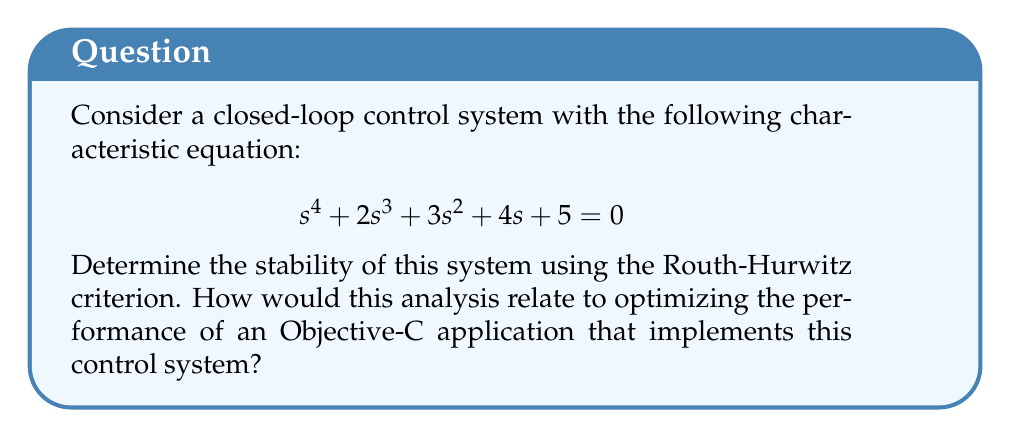Teach me how to tackle this problem. To determine the stability of the system using the Routh-Hurwitz criterion, we'll follow these steps:

1. Construct the Routh array:

   $$\begin{array}{c|cccc}
   s^4 & 1 & 3 & 5 \\
   s^3 & 2 & 4 & 0 \\
   s^2 & b_1 & b_2 & \\
   s^1 & c_1 & & \\
   s^0 & d_1 & & 
   \end{array}$$

2. Calculate the elements of the array:

   $b_1 = \frac{(2)(3) - (1)(4)}{2} = 1$
   
   $b_2 = \frac{(2)(5) - (1)(0)}{2} = 5$
   
   $c_1 = \frac{(1)(4) - (2)(5)}{1} = -6$
   
   $d_1 = 5$ (last element of the first column)

3. The complete Routh array:

   $$\begin{array}{c|cccc}
   s^4 & 1 & 3 & 5 \\
   s^3 & 2 & 4 & 0 \\
   s^2 & 1 & 5 & \\
   s^1 & -6 & & \\
   s^0 & 5 & & 
   \end{array}$$

4. Analyze the first column of the Routh array:
   - There is a sign change between -6 and 5 in the first column.
   - According to the Routh-Hurwitz criterion, the number of sign changes in the first column equals the number of roots with positive real parts.

5. Conclusion: The system is unstable because there is one sign change in the first column, indicating one root with a positive real part.

Relating this to Objective-C performance optimization:

1. In an Objective-C application implementing this control system, instability could lead to unpredictable behavior and potential crashes.
2. To optimize performance, you would need to adjust the system parameters to achieve stability.
3. You could implement the Routh-Hurwitz criterion as an efficient algorithm in Objective-C to quickly assess stability for various parameter combinations.
4. Use of Grand Central Dispatch (GCD) could parallelize the stability analysis for multiple parameter sets, improving overall application performance.
5. Proper memory management and use of Automatic Reference Counting (ARC) would be crucial when dealing with complex mathematical operations to prevent memory leaks and optimize resource usage.
Answer: Unstable; 1 sign change in Routh array's first column 